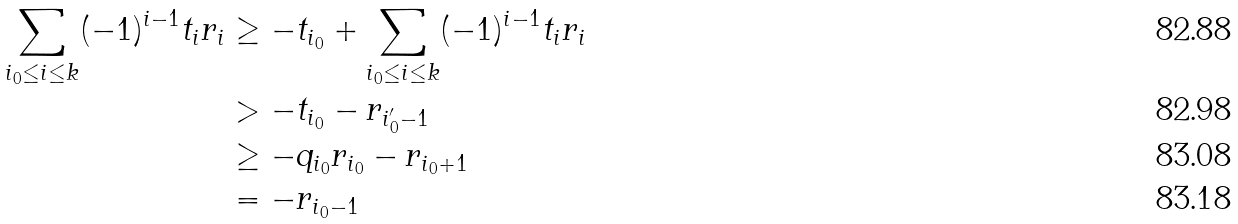Convert formula to latex. <formula><loc_0><loc_0><loc_500><loc_500>\sum _ { i _ { 0 } \leq i \leq k } ( - 1 ) ^ { i - 1 } t _ { i } r _ { i } & \geq - t _ { i _ { 0 } } + \sum _ { i _ { 0 } \leq i \leq k } ( - 1 ) ^ { i - 1 } t _ { i } r _ { i } \\ & > - t _ { i _ { 0 } } - r _ { i ^ { \prime } _ { 0 } - 1 } \\ & \geq - q _ { i _ { 0 } } r _ { i _ { 0 } } - r _ { i _ { 0 } + 1 } \\ & = - r _ { i _ { 0 } - 1 }</formula> 